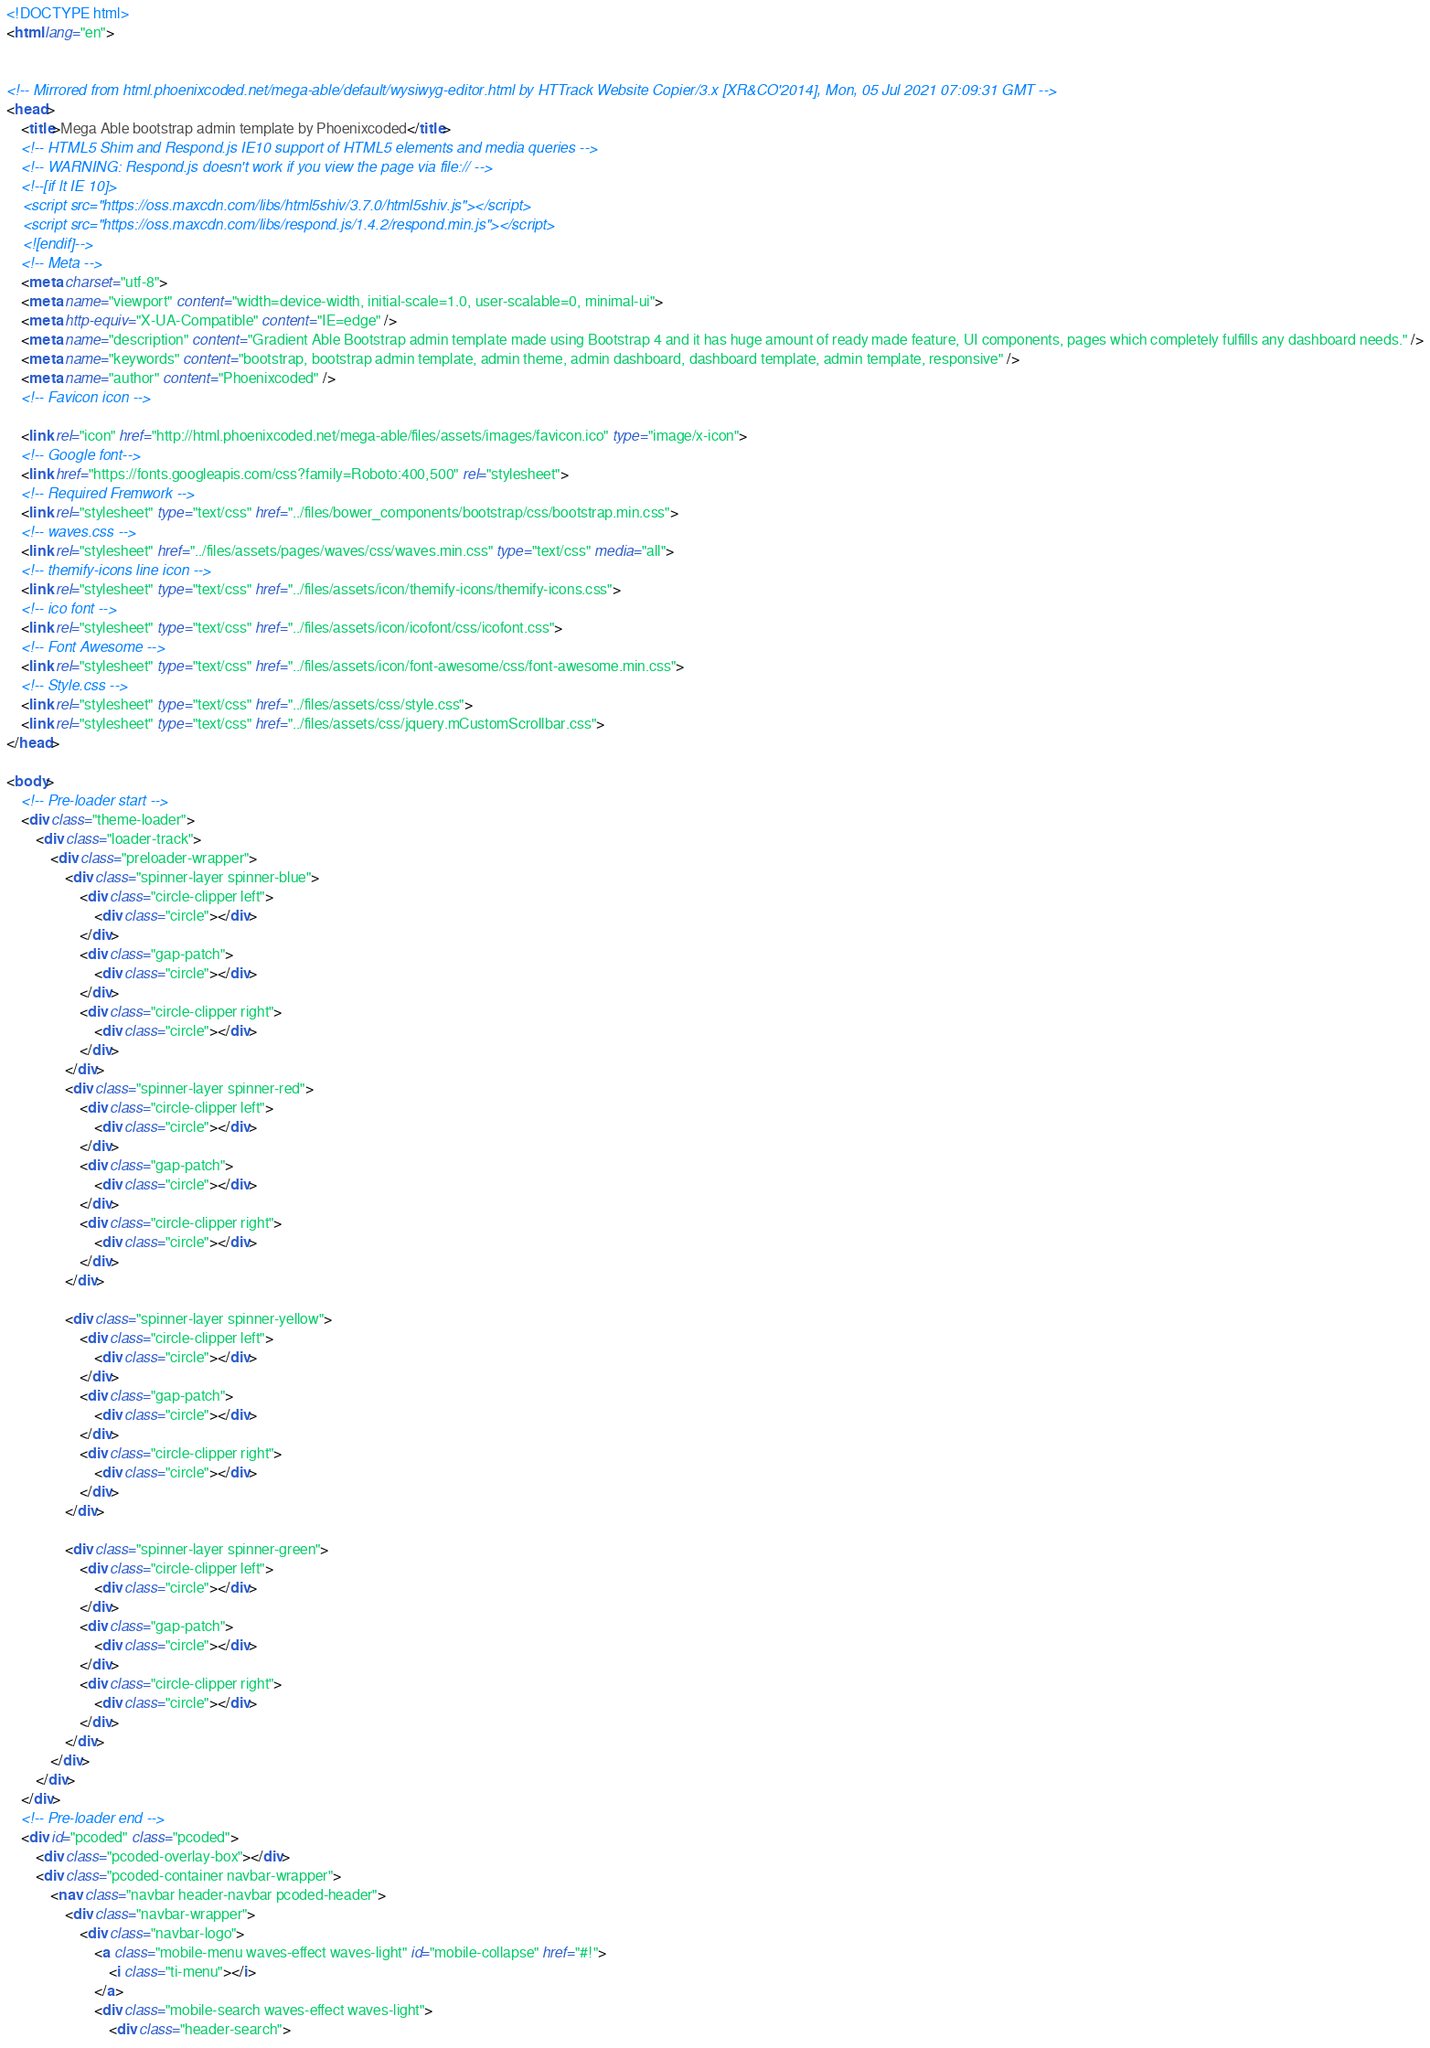Convert code to text. <code><loc_0><loc_0><loc_500><loc_500><_HTML_><!DOCTYPE html>
<html lang="en">


<!-- Mirrored from html.phoenixcoded.net/mega-able/default/wysiwyg-editor.html by HTTrack Website Copier/3.x [XR&CO'2014], Mon, 05 Jul 2021 07:09:31 GMT -->
<head>
    <title>Mega Able bootstrap admin template by Phoenixcoded</title>
    <!-- HTML5 Shim and Respond.js IE10 support of HTML5 elements and media queries -->
    <!-- WARNING: Respond.js doesn't work if you view the page via file:// -->
    <!--[if lt IE 10]>
    <script src="https://oss.maxcdn.com/libs/html5shiv/3.7.0/html5shiv.js"></script>
    <script src="https://oss.maxcdn.com/libs/respond.js/1.4.2/respond.min.js"></script>
    <![endif]-->
    <!-- Meta -->
    <meta charset="utf-8">
    <meta name="viewport" content="width=device-width, initial-scale=1.0, user-scalable=0, minimal-ui">
    <meta http-equiv="X-UA-Compatible" content="IE=edge" />
    <meta name="description" content="Gradient Able Bootstrap admin template made using Bootstrap 4 and it has huge amount of ready made feature, UI components, pages which completely fulfills any dashboard needs." />
    <meta name="keywords" content="bootstrap, bootstrap admin template, admin theme, admin dashboard, dashboard template, admin template, responsive" />
    <meta name="author" content="Phoenixcoded" />
    <!-- Favicon icon -->
    
    <link rel="icon" href="http://html.phoenixcoded.net/mega-able/files/assets/images/favicon.ico" type="image/x-icon">
    <!-- Google font-->     
    <link href="https://fonts.googleapis.com/css?family=Roboto:400,500" rel="stylesheet">
    <!-- Required Fremwork -->
    <link rel="stylesheet" type="text/css" href="../files/bower_components/bootstrap/css/bootstrap.min.css">
    <!-- waves.css -->
    <link rel="stylesheet" href="../files/assets/pages/waves/css/waves.min.css" type="text/css" media="all">
    <!-- themify-icons line icon -->
    <link rel="stylesheet" type="text/css" href="../files/assets/icon/themify-icons/themify-icons.css">
    <!-- ico font -->
    <link rel="stylesheet" type="text/css" href="../files/assets/icon/icofont/css/icofont.css">
    <!-- Font Awesome -->
    <link rel="stylesheet" type="text/css" href="../files/assets/icon/font-awesome/css/font-awesome.min.css">
    <!-- Style.css -->
    <link rel="stylesheet" type="text/css" href="../files/assets/css/style.css">
    <link rel="stylesheet" type="text/css" href="../files/assets/css/jquery.mCustomScrollbar.css">
</head>

<body>
    <!-- Pre-loader start -->
    <div class="theme-loader">
        <div class="loader-track">
            <div class="preloader-wrapper">
                <div class="spinner-layer spinner-blue">
                    <div class="circle-clipper left">
                        <div class="circle"></div>
                    </div>
                    <div class="gap-patch">
                        <div class="circle"></div>
                    </div>
                    <div class="circle-clipper right">
                        <div class="circle"></div>
                    </div>
                </div>
                <div class="spinner-layer spinner-red">
                    <div class="circle-clipper left">
                        <div class="circle"></div>
                    </div>
                    <div class="gap-patch">
                        <div class="circle"></div>
                    </div>
                    <div class="circle-clipper right">
                        <div class="circle"></div>
                    </div>
                </div>
                
                <div class="spinner-layer spinner-yellow">
                    <div class="circle-clipper left">
                        <div class="circle"></div>
                    </div>
                    <div class="gap-patch">
                        <div class="circle"></div>
                    </div>
                    <div class="circle-clipper right">
                        <div class="circle"></div>
                    </div>
                </div>
                
                <div class="spinner-layer spinner-green">
                    <div class="circle-clipper left">
                        <div class="circle"></div>
                    </div>
                    <div class="gap-patch">
                        <div class="circle"></div>
                    </div>
                    <div class="circle-clipper right">
                        <div class="circle"></div>
                    </div>
                </div>
            </div>
        </div>
    </div>
    <!-- Pre-loader end -->
    <div id="pcoded" class="pcoded">
        <div class="pcoded-overlay-box"></div>
        <div class="pcoded-container navbar-wrapper">
            <nav class="navbar header-navbar pcoded-header">
                <div class="navbar-wrapper">
                    <div class="navbar-logo">
                        <a class="mobile-menu waves-effect waves-light" id="mobile-collapse" href="#!">
                            <i class="ti-menu"></i>
                        </a>
                        <div class="mobile-search waves-effect waves-light">
                            <div class="header-search"></code> 